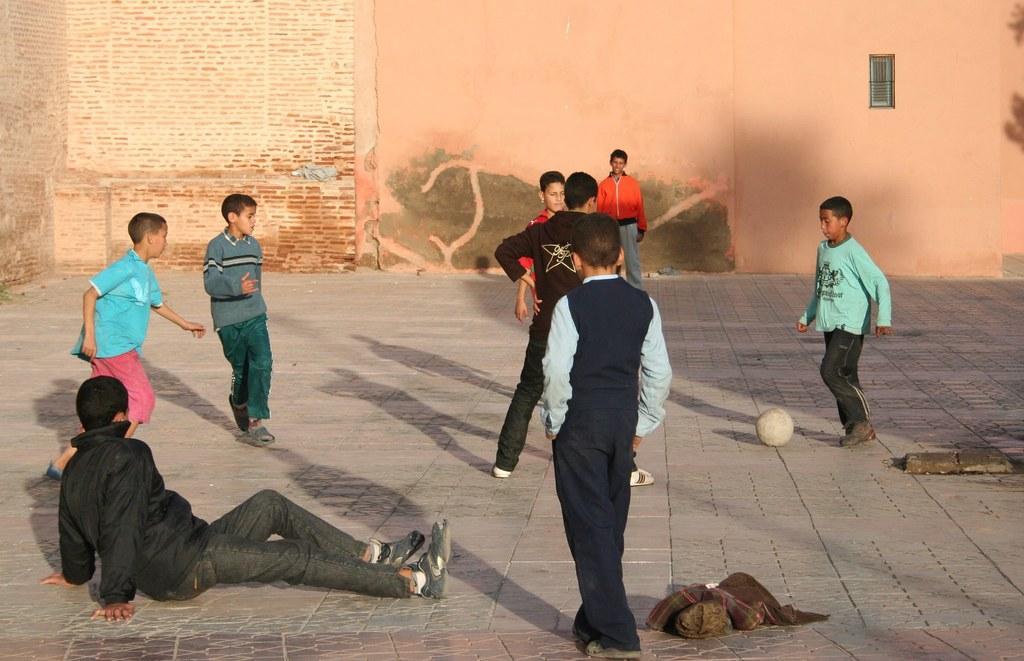In one or two sentences, can you explain what this image depicts? In this image I can see few kids playing. I can see a ball. In the background there is a wall. I can see a window. 